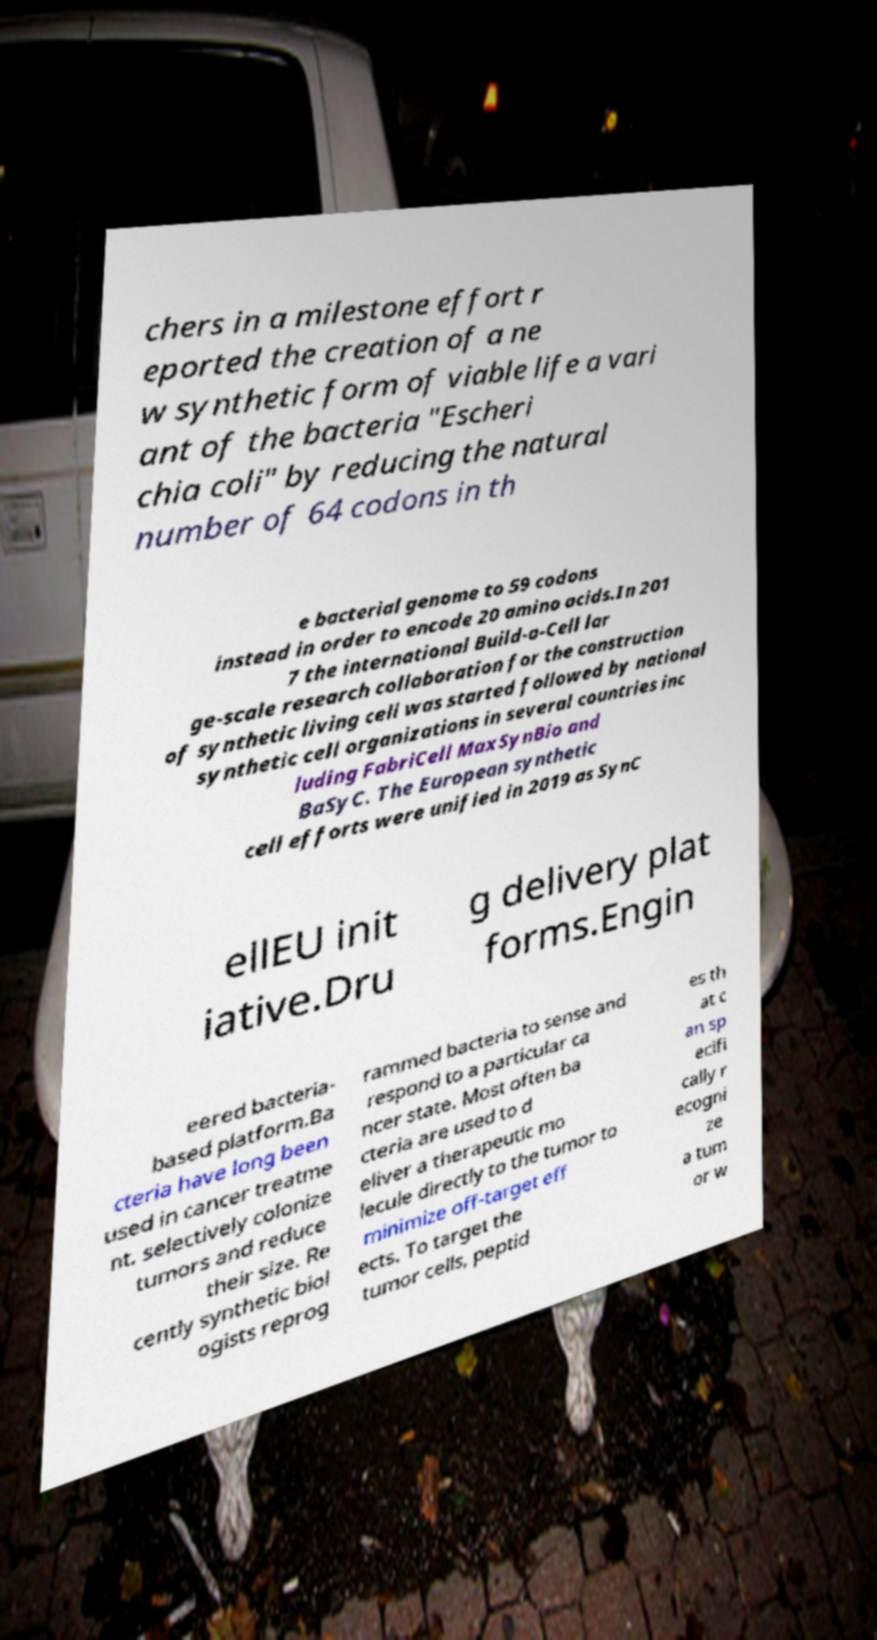Please read and relay the text visible in this image. What does it say? chers in a milestone effort r eported the creation of a ne w synthetic form of viable life a vari ant of the bacteria "Escheri chia coli" by reducing the natural number of 64 codons in th e bacterial genome to 59 codons instead in order to encode 20 amino acids.In 201 7 the international Build-a-Cell lar ge-scale research collaboration for the construction of synthetic living cell was started followed by national synthetic cell organizations in several countries inc luding FabriCell MaxSynBio and BaSyC. The European synthetic cell efforts were unified in 2019 as SynC ellEU init iative.Dru g delivery plat forms.Engin eered bacteria- based platform.Ba cteria have long been used in cancer treatme nt. selectively colonize tumors and reduce their size. Re cently synthetic biol ogists reprog rammed bacteria to sense and respond to a particular ca ncer state. Most often ba cteria are used to d eliver a therapeutic mo lecule directly to the tumor to minimize off-target eff ects. To target the tumor cells, peptid es th at c an sp ecifi cally r ecogni ze a tum or w 